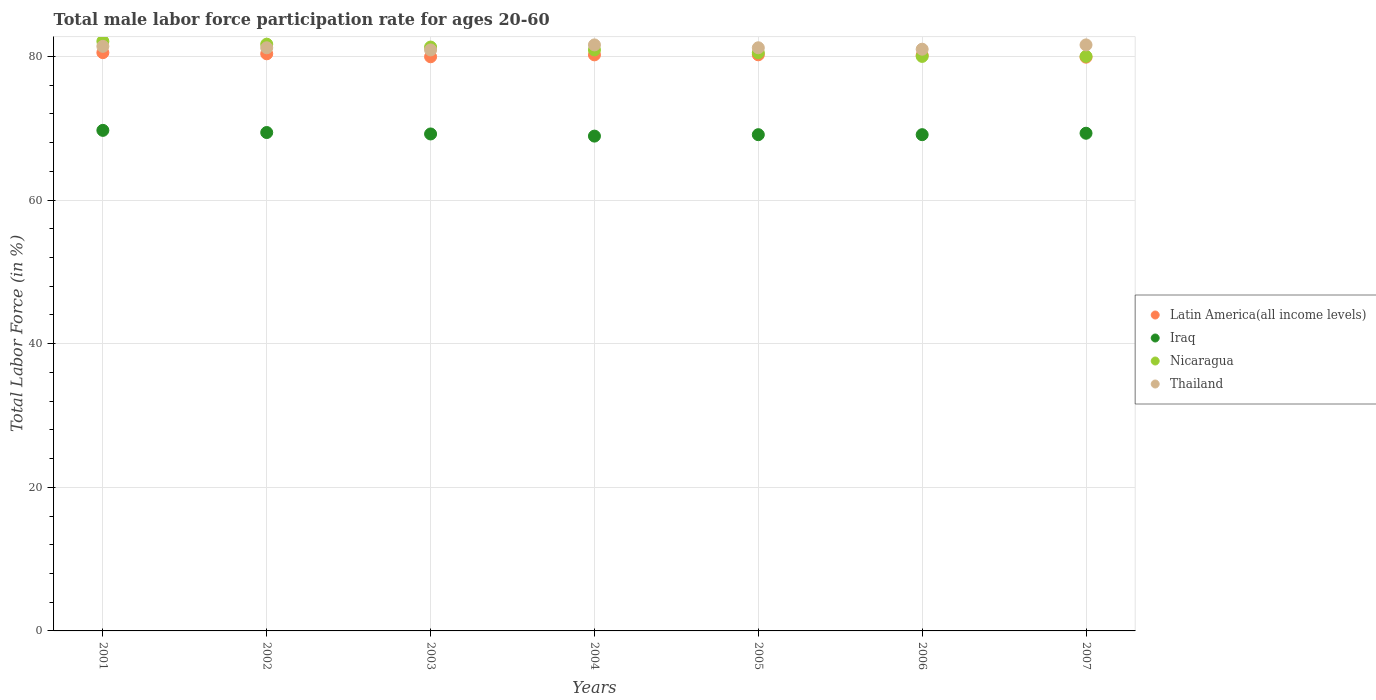What is the male labor force participation rate in Iraq in 2001?
Offer a terse response. 69.7. Across all years, what is the maximum male labor force participation rate in Thailand?
Your answer should be compact. 81.6. In which year was the male labor force participation rate in Thailand maximum?
Your response must be concise. 2004. In which year was the male labor force participation rate in Latin America(all income levels) minimum?
Your answer should be compact. 2007. What is the total male labor force participation rate in Nicaragua in the graph?
Ensure brevity in your answer.  566.5. What is the difference between the male labor force participation rate in Iraq in 2003 and that in 2004?
Your answer should be compact. 0.3. What is the difference between the male labor force participation rate in Latin America(all income levels) in 2006 and the male labor force participation rate in Nicaragua in 2001?
Offer a terse response. -1.94. What is the average male labor force participation rate in Thailand per year?
Give a very brief answer. 81.27. In the year 2006, what is the difference between the male labor force participation rate in Iraq and male labor force participation rate in Thailand?
Offer a very short reply. -11.9. What is the ratio of the male labor force participation rate in Latin America(all income levels) in 2003 to that in 2004?
Make the answer very short. 1. What is the difference between the highest and the second highest male labor force participation rate in Iraq?
Your answer should be very brief. 0.3. What is the difference between the highest and the lowest male labor force participation rate in Latin America(all income levels)?
Provide a succinct answer. 0.63. In how many years, is the male labor force participation rate in Thailand greater than the average male labor force participation rate in Thailand taken over all years?
Your answer should be very brief. 3. Is it the case that in every year, the sum of the male labor force participation rate in Iraq and male labor force participation rate in Latin America(all income levels)  is greater than the sum of male labor force participation rate in Thailand and male labor force participation rate in Nicaragua?
Provide a succinct answer. No. Does the male labor force participation rate in Latin America(all income levels) monotonically increase over the years?
Your answer should be compact. No. Is the male labor force participation rate in Nicaragua strictly less than the male labor force participation rate in Latin America(all income levels) over the years?
Your response must be concise. No. How many dotlines are there?
Offer a terse response. 4. How many years are there in the graph?
Your answer should be compact. 7. What is the difference between two consecutive major ticks on the Y-axis?
Ensure brevity in your answer.  20. Are the values on the major ticks of Y-axis written in scientific E-notation?
Provide a short and direct response. No. How many legend labels are there?
Offer a very short reply. 4. What is the title of the graph?
Keep it short and to the point. Total male labor force participation rate for ages 20-60. Does "Macao" appear as one of the legend labels in the graph?
Ensure brevity in your answer.  No. What is the label or title of the Y-axis?
Offer a very short reply. Total Labor Force (in %). What is the Total Labor Force (in %) in Latin America(all income levels) in 2001?
Make the answer very short. 80.52. What is the Total Labor Force (in %) in Iraq in 2001?
Your response must be concise. 69.7. What is the Total Labor Force (in %) in Nicaragua in 2001?
Your answer should be very brief. 82.1. What is the Total Labor Force (in %) of Thailand in 2001?
Ensure brevity in your answer.  81.4. What is the Total Labor Force (in %) in Latin America(all income levels) in 2002?
Ensure brevity in your answer.  80.36. What is the Total Labor Force (in %) in Iraq in 2002?
Offer a very short reply. 69.4. What is the Total Labor Force (in %) in Nicaragua in 2002?
Keep it short and to the point. 81.7. What is the Total Labor Force (in %) of Thailand in 2002?
Your response must be concise. 81.2. What is the Total Labor Force (in %) in Latin America(all income levels) in 2003?
Give a very brief answer. 79.95. What is the Total Labor Force (in %) of Iraq in 2003?
Ensure brevity in your answer.  69.2. What is the Total Labor Force (in %) in Nicaragua in 2003?
Your answer should be compact. 81.3. What is the Total Labor Force (in %) of Thailand in 2003?
Provide a short and direct response. 80.9. What is the Total Labor Force (in %) in Latin America(all income levels) in 2004?
Offer a very short reply. 80.22. What is the Total Labor Force (in %) in Iraq in 2004?
Your answer should be compact. 68.9. What is the Total Labor Force (in %) of Nicaragua in 2004?
Your answer should be very brief. 80.9. What is the Total Labor Force (in %) of Thailand in 2004?
Give a very brief answer. 81.6. What is the Total Labor Force (in %) in Latin America(all income levels) in 2005?
Provide a succinct answer. 80.22. What is the Total Labor Force (in %) in Iraq in 2005?
Your response must be concise. 69.1. What is the Total Labor Force (in %) in Nicaragua in 2005?
Offer a very short reply. 80.5. What is the Total Labor Force (in %) of Thailand in 2005?
Offer a terse response. 81.2. What is the Total Labor Force (in %) in Latin America(all income levels) in 2006?
Your response must be concise. 80.16. What is the Total Labor Force (in %) of Iraq in 2006?
Offer a very short reply. 69.1. What is the Total Labor Force (in %) in Thailand in 2006?
Offer a very short reply. 81. What is the Total Labor Force (in %) of Latin America(all income levels) in 2007?
Your answer should be very brief. 79.89. What is the Total Labor Force (in %) in Iraq in 2007?
Provide a succinct answer. 69.3. What is the Total Labor Force (in %) in Nicaragua in 2007?
Make the answer very short. 80. What is the Total Labor Force (in %) in Thailand in 2007?
Provide a succinct answer. 81.6. Across all years, what is the maximum Total Labor Force (in %) in Latin America(all income levels)?
Your answer should be very brief. 80.52. Across all years, what is the maximum Total Labor Force (in %) in Iraq?
Your answer should be compact. 69.7. Across all years, what is the maximum Total Labor Force (in %) in Nicaragua?
Provide a short and direct response. 82.1. Across all years, what is the maximum Total Labor Force (in %) in Thailand?
Give a very brief answer. 81.6. Across all years, what is the minimum Total Labor Force (in %) of Latin America(all income levels)?
Your response must be concise. 79.89. Across all years, what is the minimum Total Labor Force (in %) in Iraq?
Make the answer very short. 68.9. Across all years, what is the minimum Total Labor Force (in %) of Thailand?
Provide a short and direct response. 80.9. What is the total Total Labor Force (in %) in Latin America(all income levels) in the graph?
Offer a terse response. 561.32. What is the total Total Labor Force (in %) in Iraq in the graph?
Your answer should be very brief. 484.7. What is the total Total Labor Force (in %) in Nicaragua in the graph?
Your answer should be compact. 566.5. What is the total Total Labor Force (in %) of Thailand in the graph?
Provide a short and direct response. 568.9. What is the difference between the Total Labor Force (in %) in Latin America(all income levels) in 2001 and that in 2002?
Give a very brief answer. 0.16. What is the difference between the Total Labor Force (in %) in Thailand in 2001 and that in 2002?
Keep it short and to the point. 0.2. What is the difference between the Total Labor Force (in %) of Latin America(all income levels) in 2001 and that in 2003?
Provide a succinct answer. 0.57. What is the difference between the Total Labor Force (in %) in Latin America(all income levels) in 2001 and that in 2004?
Your answer should be compact. 0.3. What is the difference between the Total Labor Force (in %) of Nicaragua in 2001 and that in 2004?
Provide a short and direct response. 1.2. What is the difference between the Total Labor Force (in %) in Latin America(all income levels) in 2001 and that in 2005?
Your answer should be compact. 0.3. What is the difference between the Total Labor Force (in %) of Nicaragua in 2001 and that in 2005?
Keep it short and to the point. 1.6. What is the difference between the Total Labor Force (in %) of Thailand in 2001 and that in 2005?
Provide a short and direct response. 0.2. What is the difference between the Total Labor Force (in %) of Latin America(all income levels) in 2001 and that in 2006?
Offer a terse response. 0.36. What is the difference between the Total Labor Force (in %) of Iraq in 2001 and that in 2006?
Provide a succinct answer. 0.6. What is the difference between the Total Labor Force (in %) in Nicaragua in 2001 and that in 2006?
Offer a very short reply. 2.1. What is the difference between the Total Labor Force (in %) in Thailand in 2001 and that in 2006?
Provide a short and direct response. 0.4. What is the difference between the Total Labor Force (in %) of Latin America(all income levels) in 2001 and that in 2007?
Give a very brief answer. 0.63. What is the difference between the Total Labor Force (in %) of Iraq in 2001 and that in 2007?
Give a very brief answer. 0.4. What is the difference between the Total Labor Force (in %) of Thailand in 2001 and that in 2007?
Offer a terse response. -0.2. What is the difference between the Total Labor Force (in %) of Latin America(all income levels) in 2002 and that in 2003?
Make the answer very short. 0.42. What is the difference between the Total Labor Force (in %) of Iraq in 2002 and that in 2003?
Keep it short and to the point. 0.2. What is the difference between the Total Labor Force (in %) of Thailand in 2002 and that in 2003?
Offer a terse response. 0.3. What is the difference between the Total Labor Force (in %) in Latin America(all income levels) in 2002 and that in 2004?
Keep it short and to the point. 0.15. What is the difference between the Total Labor Force (in %) in Iraq in 2002 and that in 2004?
Provide a short and direct response. 0.5. What is the difference between the Total Labor Force (in %) of Latin America(all income levels) in 2002 and that in 2005?
Ensure brevity in your answer.  0.14. What is the difference between the Total Labor Force (in %) in Nicaragua in 2002 and that in 2005?
Provide a succinct answer. 1.2. What is the difference between the Total Labor Force (in %) of Latin America(all income levels) in 2002 and that in 2006?
Give a very brief answer. 0.2. What is the difference between the Total Labor Force (in %) of Latin America(all income levels) in 2002 and that in 2007?
Your response must be concise. 0.47. What is the difference between the Total Labor Force (in %) in Iraq in 2002 and that in 2007?
Make the answer very short. 0.1. What is the difference between the Total Labor Force (in %) in Nicaragua in 2002 and that in 2007?
Keep it short and to the point. 1.7. What is the difference between the Total Labor Force (in %) of Latin America(all income levels) in 2003 and that in 2004?
Keep it short and to the point. -0.27. What is the difference between the Total Labor Force (in %) of Thailand in 2003 and that in 2004?
Your response must be concise. -0.7. What is the difference between the Total Labor Force (in %) in Latin America(all income levels) in 2003 and that in 2005?
Provide a succinct answer. -0.27. What is the difference between the Total Labor Force (in %) in Nicaragua in 2003 and that in 2005?
Keep it short and to the point. 0.8. What is the difference between the Total Labor Force (in %) in Thailand in 2003 and that in 2005?
Ensure brevity in your answer.  -0.3. What is the difference between the Total Labor Force (in %) of Latin America(all income levels) in 2003 and that in 2006?
Keep it short and to the point. -0.21. What is the difference between the Total Labor Force (in %) in Nicaragua in 2003 and that in 2006?
Provide a short and direct response. 1.3. What is the difference between the Total Labor Force (in %) in Thailand in 2003 and that in 2006?
Your answer should be very brief. -0.1. What is the difference between the Total Labor Force (in %) of Latin America(all income levels) in 2003 and that in 2007?
Your answer should be compact. 0.06. What is the difference between the Total Labor Force (in %) in Iraq in 2003 and that in 2007?
Give a very brief answer. -0.1. What is the difference between the Total Labor Force (in %) of Thailand in 2003 and that in 2007?
Keep it short and to the point. -0.7. What is the difference between the Total Labor Force (in %) in Latin America(all income levels) in 2004 and that in 2005?
Offer a terse response. -0.01. What is the difference between the Total Labor Force (in %) in Iraq in 2004 and that in 2005?
Provide a succinct answer. -0.2. What is the difference between the Total Labor Force (in %) in Nicaragua in 2004 and that in 2005?
Provide a short and direct response. 0.4. What is the difference between the Total Labor Force (in %) of Thailand in 2004 and that in 2005?
Offer a terse response. 0.4. What is the difference between the Total Labor Force (in %) in Latin America(all income levels) in 2004 and that in 2006?
Keep it short and to the point. 0.05. What is the difference between the Total Labor Force (in %) of Nicaragua in 2004 and that in 2006?
Keep it short and to the point. 0.9. What is the difference between the Total Labor Force (in %) in Thailand in 2004 and that in 2006?
Your answer should be compact. 0.6. What is the difference between the Total Labor Force (in %) in Latin America(all income levels) in 2004 and that in 2007?
Provide a succinct answer. 0.32. What is the difference between the Total Labor Force (in %) in Latin America(all income levels) in 2005 and that in 2006?
Give a very brief answer. 0.06. What is the difference between the Total Labor Force (in %) in Iraq in 2005 and that in 2006?
Ensure brevity in your answer.  0. What is the difference between the Total Labor Force (in %) of Thailand in 2005 and that in 2006?
Keep it short and to the point. 0.2. What is the difference between the Total Labor Force (in %) in Latin America(all income levels) in 2005 and that in 2007?
Provide a short and direct response. 0.33. What is the difference between the Total Labor Force (in %) of Iraq in 2005 and that in 2007?
Ensure brevity in your answer.  -0.2. What is the difference between the Total Labor Force (in %) of Thailand in 2005 and that in 2007?
Provide a short and direct response. -0.4. What is the difference between the Total Labor Force (in %) in Latin America(all income levels) in 2006 and that in 2007?
Your answer should be compact. 0.27. What is the difference between the Total Labor Force (in %) in Nicaragua in 2006 and that in 2007?
Your response must be concise. 0. What is the difference between the Total Labor Force (in %) of Latin America(all income levels) in 2001 and the Total Labor Force (in %) of Iraq in 2002?
Your response must be concise. 11.12. What is the difference between the Total Labor Force (in %) in Latin America(all income levels) in 2001 and the Total Labor Force (in %) in Nicaragua in 2002?
Give a very brief answer. -1.18. What is the difference between the Total Labor Force (in %) of Latin America(all income levels) in 2001 and the Total Labor Force (in %) of Thailand in 2002?
Your response must be concise. -0.68. What is the difference between the Total Labor Force (in %) of Iraq in 2001 and the Total Labor Force (in %) of Nicaragua in 2002?
Offer a terse response. -12. What is the difference between the Total Labor Force (in %) in Iraq in 2001 and the Total Labor Force (in %) in Thailand in 2002?
Your response must be concise. -11.5. What is the difference between the Total Labor Force (in %) in Latin America(all income levels) in 2001 and the Total Labor Force (in %) in Iraq in 2003?
Your response must be concise. 11.32. What is the difference between the Total Labor Force (in %) of Latin America(all income levels) in 2001 and the Total Labor Force (in %) of Nicaragua in 2003?
Provide a succinct answer. -0.78. What is the difference between the Total Labor Force (in %) of Latin America(all income levels) in 2001 and the Total Labor Force (in %) of Thailand in 2003?
Ensure brevity in your answer.  -0.38. What is the difference between the Total Labor Force (in %) in Iraq in 2001 and the Total Labor Force (in %) in Nicaragua in 2003?
Provide a short and direct response. -11.6. What is the difference between the Total Labor Force (in %) in Latin America(all income levels) in 2001 and the Total Labor Force (in %) in Iraq in 2004?
Give a very brief answer. 11.62. What is the difference between the Total Labor Force (in %) of Latin America(all income levels) in 2001 and the Total Labor Force (in %) of Nicaragua in 2004?
Ensure brevity in your answer.  -0.38. What is the difference between the Total Labor Force (in %) in Latin America(all income levels) in 2001 and the Total Labor Force (in %) in Thailand in 2004?
Provide a short and direct response. -1.08. What is the difference between the Total Labor Force (in %) in Latin America(all income levels) in 2001 and the Total Labor Force (in %) in Iraq in 2005?
Give a very brief answer. 11.42. What is the difference between the Total Labor Force (in %) in Latin America(all income levels) in 2001 and the Total Labor Force (in %) in Nicaragua in 2005?
Keep it short and to the point. 0.02. What is the difference between the Total Labor Force (in %) in Latin America(all income levels) in 2001 and the Total Labor Force (in %) in Thailand in 2005?
Make the answer very short. -0.68. What is the difference between the Total Labor Force (in %) in Iraq in 2001 and the Total Labor Force (in %) in Nicaragua in 2005?
Offer a very short reply. -10.8. What is the difference between the Total Labor Force (in %) in Iraq in 2001 and the Total Labor Force (in %) in Thailand in 2005?
Your answer should be very brief. -11.5. What is the difference between the Total Labor Force (in %) in Latin America(all income levels) in 2001 and the Total Labor Force (in %) in Iraq in 2006?
Offer a terse response. 11.42. What is the difference between the Total Labor Force (in %) of Latin America(all income levels) in 2001 and the Total Labor Force (in %) of Nicaragua in 2006?
Make the answer very short. 0.52. What is the difference between the Total Labor Force (in %) in Latin America(all income levels) in 2001 and the Total Labor Force (in %) in Thailand in 2006?
Keep it short and to the point. -0.48. What is the difference between the Total Labor Force (in %) in Iraq in 2001 and the Total Labor Force (in %) in Thailand in 2006?
Your response must be concise. -11.3. What is the difference between the Total Labor Force (in %) in Nicaragua in 2001 and the Total Labor Force (in %) in Thailand in 2006?
Provide a succinct answer. 1.1. What is the difference between the Total Labor Force (in %) in Latin America(all income levels) in 2001 and the Total Labor Force (in %) in Iraq in 2007?
Offer a very short reply. 11.22. What is the difference between the Total Labor Force (in %) in Latin America(all income levels) in 2001 and the Total Labor Force (in %) in Nicaragua in 2007?
Ensure brevity in your answer.  0.52. What is the difference between the Total Labor Force (in %) in Latin America(all income levels) in 2001 and the Total Labor Force (in %) in Thailand in 2007?
Your answer should be compact. -1.08. What is the difference between the Total Labor Force (in %) of Latin America(all income levels) in 2002 and the Total Labor Force (in %) of Iraq in 2003?
Give a very brief answer. 11.16. What is the difference between the Total Labor Force (in %) in Latin America(all income levels) in 2002 and the Total Labor Force (in %) in Nicaragua in 2003?
Make the answer very short. -0.94. What is the difference between the Total Labor Force (in %) in Latin America(all income levels) in 2002 and the Total Labor Force (in %) in Thailand in 2003?
Offer a terse response. -0.54. What is the difference between the Total Labor Force (in %) in Iraq in 2002 and the Total Labor Force (in %) in Nicaragua in 2003?
Offer a terse response. -11.9. What is the difference between the Total Labor Force (in %) in Nicaragua in 2002 and the Total Labor Force (in %) in Thailand in 2003?
Your answer should be compact. 0.8. What is the difference between the Total Labor Force (in %) of Latin America(all income levels) in 2002 and the Total Labor Force (in %) of Iraq in 2004?
Provide a short and direct response. 11.46. What is the difference between the Total Labor Force (in %) in Latin America(all income levels) in 2002 and the Total Labor Force (in %) in Nicaragua in 2004?
Make the answer very short. -0.54. What is the difference between the Total Labor Force (in %) of Latin America(all income levels) in 2002 and the Total Labor Force (in %) of Thailand in 2004?
Ensure brevity in your answer.  -1.24. What is the difference between the Total Labor Force (in %) in Iraq in 2002 and the Total Labor Force (in %) in Nicaragua in 2004?
Your answer should be compact. -11.5. What is the difference between the Total Labor Force (in %) in Nicaragua in 2002 and the Total Labor Force (in %) in Thailand in 2004?
Your answer should be very brief. 0.1. What is the difference between the Total Labor Force (in %) in Latin America(all income levels) in 2002 and the Total Labor Force (in %) in Iraq in 2005?
Your answer should be compact. 11.26. What is the difference between the Total Labor Force (in %) of Latin America(all income levels) in 2002 and the Total Labor Force (in %) of Nicaragua in 2005?
Give a very brief answer. -0.14. What is the difference between the Total Labor Force (in %) in Latin America(all income levels) in 2002 and the Total Labor Force (in %) in Thailand in 2005?
Ensure brevity in your answer.  -0.84. What is the difference between the Total Labor Force (in %) in Iraq in 2002 and the Total Labor Force (in %) in Thailand in 2005?
Keep it short and to the point. -11.8. What is the difference between the Total Labor Force (in %) in Latin America(all income levels) in 2002 and the Total Labor Force (in %) in Iraq in 2006?
Offer a very short reply. 11.26. What is the difference between the Total Labor Force (in %) of Latin America(all income levels) in 2002 and the Total Labor Force (in %) of Nicaragua in 2006?
Your answer should be compact. 0.36. What is the difference between the Total Labor Force (in %) in Latin America(all income levels) in 2002 and the Total Labor Force (in %) in Thailand in 2006?
Provide a short and direct response. -0.64. What is the difference between the Total Labor Force (in %) in Nicaragua in 2002 and the Total Labor Force (in %) in Thailand in 2006?
Offer a very short reply. 0.7. What is the difference between the Total Labor Force (in %) of Latin America(all income levels) in 2002 and the Total Labor Force (in %) of Iraq in 2007?
Ensure brevity in your answer.  11.06. What is the difference between the Total Labor Force (in %) in Latin America(all income levels) in 2002 and the Total Labor Force (in %) in Nicaragua in 2007?
Offer a very short reply. 0.36. What is the difference between the Total Labor Force (in %) of Latin America(all income levels) in 2002 and the Total Labor Force (in %) of Thailand in 2007?
Provide a succinct answer. -1.24. What is the difference between the Total Labor Force (in %) of Nicaragua in 2002 and the Total Labor Force (in %) of Thailand in 2007?
Your answer should be compact. 0.1. What is the difference between the Total Labor Force (in %) of Latin America(all income levels) in 2003 and the Total Labor Force (in %) of Iraq in 2004?
Make the answer very short. 11.05. What is the difference between the Total Labor Force (in %) in Latin America(all income levels) in 2003 and the Total Labor Force (in %) in Nicaragua in 2004?
Offer a very short reply. -0.95. What is the difference between the Total Labor Force (in %) of Latin America(all income levels) in 2003 and the Total Labor Force (in %) of Thailand in 2004?
Ensure brevity in your answer.  -1.65. What is the difference between the Total Labor Force (in %) of Iraq in 2003 and the Total Labor Force (in %) of Nicaragua in 2004?
Offer a very short reply. -11.7. What is the difference between the Total Labor Force (in %) of Iraq in 2003 and the Total Labor Force (in %) of Thailand in 2004?
Provide a short and direct response. -12.4. What is the difference between the Total Labor Force (in %) of Latin America(all income levels) in 2003 and the Total Labor Force (in %) of Iraq in 2005?
Keep it short and to the point. 10.85. What is the difference between the Total Labor Force (in %) in Latin America(all income levels) in 2003 and the Total Labor Force (in %) in Nicaragua in 2005?
Make the answer very short. -0.55. What is the difference between the Total Labor Force (in %) in Latin America(all income levels) in 2003 and the Total Labor Force (in %) in Thailand in 2005?
Offer a terse response. -1.25. What is the difference between the Total Labor Force (in %) of Iraq in 2003 and the Total Labor Force (in %) of Thailand in 2005?
Your answer should be compact. -12. What is the difference between the Total Labor Force (in %) of Nicaragua in 2003 and the Total Labor Force (in %) of Thailand in 2005?
Your response must be concise. 0.1. What is the difference between the Total Labor Force (in %) in Latin America(all income levels) in 2003 and the Total Labor Force (in %) in Iraq in 2006?
Offer a very short reply. 10.85. What is the difference between the Total Labor Force (in %) in Latin America(all income levels) in 2003 and the Total Labor Force (in %) in Nicaragua in 2006?
Offer a terse response. -0.05. What is the difference between the Total Labor Force (in %) in Latin America(all income levels) in 2003 and the Total Labor Force (in %) in Thailand in 2006?
Provide a succinct answer. -1.05. What is the difference between the Total Labor Force (in %) of Iraq in 2003 and the Total Labor Force (in %) of Thailand in 2006?
Provide a succinct answer. -11.8. What is the difference between the Total Labor Force (in %) of Latin America(all income levels) in 2003 and the Total Labor Force (in %) of Iraq in 2007?
Provide a short and direct response. 10.65. What is the difference between the Total Labor Force (in %) in Latin America(all income levels) in 2003 and the Total Labor Force (in %) in Nicaragua in 2007?
Make the answer very short. -0.05. What is the difference between the Total Labor Force (in %) in Latin America(all income levels) in 2003 and the Total Labor Force (in %) in Thailand in 2007?
Your answer should be very brief. -1.65. What is the difference between the Total Labor Force (in %) in Latin America(all income levels) in 2004 and the Total Labor Force (in %) in Iraq in 2005?
Keep it short and to the point. 11.12. What is the difference between the Total Labor Force (in %) of Latin America(all income levels) in 2004 and the Total Labor Force (in %) of Nicaragua in 2005?
Your answer should be very brief. -0.28. What is the difference between the Total Labor Force (in %) of Latin America(all income levels) in 2004 and the Total Labor Force (in %) of Thailand in 2005?
Your response must be concise. -0.98. What is the difference between the Total Labor Force (in %) in Latin America(all income levels) in 2004 and the Total Labor Force (in %) in Iraq in 2006?
Provide a succinct answer. 11.12. What is the difference between the Total Labor Force (in %) of Latin America(all income levels) in 2004 and the Total Labor Force (in %) of Nicaragua in 2006?
Ensure brevity in your answer.  0.22. What is the difference between the Total Labor Force (in %) in Latin America(all income levels) in 2004 and the Total Labor Force (in %) in Thailand in 2006?
Give a very brief answer. -0.78. What is the difference between the Total Labor Force (in %) of Latin America(all income levels) in 2004 and the Total Labor Force (in %) of Iraq in 2007?
Ensure brevity in your answer.  10.92. What is the difference between the Total Labor Force (in %) of Latin America(all income levels) in 2004 and the Total Labor Force (in %) of Nicaragua in 2007?
Keep it short and to the point. 0.22. What is the difference between the Total Labor Force (in %) of Latin America(all income levels) in 2004 and the Total Labor Force (in %) of Thailand in 2007?
Provide a succinct answer. -1.38. What is the difference between the Total Labor Force (in %) of Iraq in 2004 and the Total Labor Force (in %) of Nicaragua in 2007?
Make the answer very short. -11.1. What is the difference between the Total Labor Force (in %) of Iraq in 2004 and the Total Labor Force (in %) of Thailand in 2007?
Your answer should be very brief. -12.7. What is the difference between the Total Labor Force (in %) in Nicaragua in 2004 and the Total Labor Force (in %) in Thailand in 2007?
Make the answer very short. -0.7. What is the difference between the Total Labor Force (in %) of Latin America(all income levels) in 2005 and the Total Labor Force (in %) of Iraq in 2006?
Provide a succinct answer. 11.12. What is the difference between the Total Labor Force (in %) of Latin America(all income levels) in 2005 and the Total Labor Force (in %) of Nicaragua in 2006?
Offer a terse response. 0.22. What is the difference between the Total Labor Force (in %) of Latin America(all income levels) in 2005 and the Total Labor Force (in %) of Thailand in 2006?
Offer a terse response. -0.78. What is the difference between the Total Labor Force (in %) in Iraq in 2005 and the Total Labor Force (in %) in Thailand in 2006?
Provide a short and direct response. -11.9. What is the difference between the Total Labor Force (in %) of Nicaragua in 2005 and the Total Labor Force (in %) of Thailand in 2006?
Offer a very short reply. -0.5. What is the difference between the Total Labor Force (in %) in Latin America(all income levels) in 2005 and the Total Labor Force (in %) in Iraq in 2007?
Your answer should be very brief. 10.92. What is the difference between the Total Labor Force (in %) in Latin America(all income levels) in 2005 and the Total Labor Force (in %) in Nicaragua in 2007?
Give a very brief answer. 0.22. What is the difference between the Total Labor Force (in %) of Latin America(all income levels) in 2005 and the Total Labor Force (in %) of Thailand in 2007?
Your answer should be compact. -1.38. What is the difference between the Total Labor Force (in %) of Iraq in 2005 and the Total Labor Force (in %) of Nicaragua in 2007?
Keep it short and to the point. -10.9. What is the difference between the Total Labor Force (in %) of Nicaragua in 2005 and the Total Labor Force (in %) of Thailand in 2007?
Provide a succinct answer. -1.1. What is the difference between the Total Labor Force (in %) in Latin America(all income levels) in 2006 and the Total Labor Force (in %) in Iraq in 2007?
Your answer should be very brief. 10.86. What is the difference between the Total Labor Force (in %) of Latin America(all income levels) in 2006 and the Total Labor Force (in %) of Nicaragua in 2007?
Your response must be concise. 0.16. What is the difference between the Total Labor Force (in %) of Latin America(all income levels) in 2006 and the Total Labor Force (in %) of Thailand in 2007?
Provide a succinct answer. -1.44. What is the average Total Labor Force (in %) in Latin America(all income levels) per year?
Provide a short and direct response. 80.19. What is the average Total Labor Force (in %) of Iraq per year?
Your answer should be very brief. 69.24. What is the average Total Labor Force (in %) of Nicaragua per year?
Make the answer very short. 80.93. What is the average Total Labor Force (in %) in Thailand per year?
Ensure brevity in your answer.  81.27. In the year 2001, what is the difference between the Total Labor Force (in %) in Latin America(all income levels) and Total Labor Force (in %) in Iraq?
Your response must be concise. 10.82. In the year 2001, what is the difference between the Total Labor Force (in %) in Latin America(all income levels) and Total Labor Force (in %) in Nicaragua?
Your answer should be very brief. -1.58. In the year 2001, what is the difference between the Total Labor Force (in %) in Latin America(all income levels) and Total Labor Force (in %) in Thailand?
Provide a succinct answer. -0.88. In the year 2001, what is the difference between the Total Labor Force (in %) of Iraq and Total Labor Force (in %) of Thailand?
Give a very brief answer. -11.7. In the year 2002, what is the difference between the Total Labor Force (in %) of Latin America(all income levels) and Total Labor Force (in %) of Iraq?
Provide a short and direct response. 10.96. In the year 2002, what is the difference between the Total Labor Force (in %) in Latin America(all income levels) and Total Labor Force (in %) in Nicaragua?
Your response must be concise. -1.34. In the year 2002, what is the difference between the Total Labor Force (in %) of Latin America(all income levels) and Total Labor Force (in %) of Thailand?
Offer a very short reply. -0.84. In the year 2002, what is the difference between the Total Labor Force (in %) of Iraq and Total Labor Force (in %) of Nicaragua?
Keep it short and to the point. -12.3. In the year 2003, what is the difference between the Total Labor Force (in %) in Latin America(all income levels) and Total Labor Force (in %) in Iraq?
Keep it short and to the point. 10.75. In the year 2003, what is the difference between the Total Labor Force (in %) in Latin America(all income levels) and Total Labor Force (in %) in Nicaragua?
Offer a very short reply. -1.35. In the year 2003, what is the difference between the Total Labor Force (in %) of Latin America(all income levels) and Total Labor Force (in %) of Thailand?
Ensure brevity in your answer.  -0.95. In the year 2003, what is the difference between the Total Labor Force (in %) of Nicaragua and Total Labor Force (in %) of Thailand?
Your answer should be very brief. 0.4. In the year 2004, what is the difference between the Total Labor Force (in %) in Latin America(all income levels) and Total Labor Force (in %) in Iraq?
Offer a terse response. 11.32. In the year 2004, what is the difference between the Total Labor Force (in %) in Latin America(all income levels) and Total Labor Force (in %) in Nicaragua?
Offer a terse response. -0.68. In the year 2004, what is the difference between the Total Labor Force (in %) in Latin America(all income levels) and Total Labor Force (in %) in Thailand?
Make the answer very short. -1.38. In the year 2004, what is the difference between the Total Labor Force (in %) of Nicaragua and Total Labor Force (in %) of Thailand?
Offer a terse response. -0.7. In the year 2005, what is the difference between the Total Labor Force (in %) of Latin America(all income levels) and Total Labor Force (in %) of Iraq?
Offer a terse response. 11.12. In the year 2005, what is the difference between the Total Labor Force (in %) of Latin America(all income levels) and Total Labor Force (in %) of Nicaragua?
Make the answer very short. -0.28. In the year 2005, what is the difference between the Total Labor Force (in %) in Latin America(all income levels) and Total Labor Force (in %) in Thailand?
Provide a short and direct response. -0.98. In the year 2005, what is the difference between the Total Labor Force (in %) of Iraq and Total Labor Force (in %) of Nicaragua?
Offer a terse response. -11.4. In the year 2005, what is the difference between the Total Labor Force (in %) in Iraq and Total Labor Force (in %) in Thailand?
Your response must be concise. -12.1. In the year 2006, what is the difference between the Total Labor Force (in %) of Latin America(all income levels) and Total Labor Force (in %) of Iraq?
Your answer should be very brief. 11.06. In the year 2006, what is the difference between the Total Labor Force (in %) in Latin America(all income levels) and Total Labor Force (in %) in Nicaragua?
Your response must be concise. 0.16. In the year 2006, what is the difference between the Total Labor Force (in %) of Latin America(all income levels) and Total Labor Force (in %) of Thailand?
Offer a very short reply. -0.84. In the year 2006, what is the difference between the Total Labor Force (in %) of Iraq and Total Labor Force (in %) of Nicaragua?
Your answer should be compact. -10.9. In the year 2006, what is the difference between the Total Labor Force (in %) of Iraq and Total Labor Force (in %) of Thailand?
Your answer should be very brief. -11.9. In the year 2007, what is the difference between the Total Labor Force (in %) of Latin America(all income levels) and Total Labor Force (in %) of Iraq?
Ensure brevity in your answer.  10.59. In the year 2007, what is the difference between the Total Labor Force (in %) in Latin America(all income levels) and Total Labor Force (in %) in Nicaragua?
Provide a succinct answer. -0.11. In the year 2007, what is the difference between the Total Labor Force (in %) of Latin America(all income levels) and Total Labor Force (in %) of Thailand?
Your answer should be compact. -1.71. In the year 2007, what is the difference between the Total Labor Force (in %) in Nicaragua and Total Labor Force (in %) in Thailand?
Provide a short and direct response. -1.6. What is the ratio of the Total Labor Force (in %) of Iraq in 2001 to that in 2002?
Give a very brief answer. 1. What is the ratio of the Total Labor Force (in %) of Nicaragua in 2001 to that in 2002?
Offer a terse response. 1. What is the ratio of the Total Labor Force (in %) in Iraq in 2001 to that in 2003?
Make the answer very short. 1.01. What is the ratio of the Total Labor Force (in %) in Nicaragua in 2001 to that in 2003?
Give a very brief answer. 1.01. What is the ratio of the Total Labor Force (in %) of Thailand in 2001 to that in 2003?
Give a very brief answer. 1.01. What is the ratio of the Total Labor Force (in %) in Iraq in 2001 to that in 2004?
Give a very brief answer. 1.01. What is the ratio of the Total Labor Force (in %) of Nicaragua in 2001 to that in 2004?
Your answer should be very brief. 1.01. What is the ratio of the Total Labor Force (in %) in Latin America(all income levels) in 2001 to that in 2005?
Keep it short and to the point. 1. What is the ratio of the Total Labor Force (in %) in Iraq in 2001 to that in 2005?
Provide a short and direct response. 1.01. What is the ratio of the Total Labor Force (in %) in Nicaragua in 2001 to that in 2005?
Keep it short and to the point. 1.02. What is the ratio of the Total Labor Force (in %) in Latin America(all income levels) in 2001 to that in 2006?
Give a very brief answer. 1. What is the ratio of the Total Labor Force (in %) of Iraq in 2001 to that in 2006?
Ensure brevity in your answer.  1.01. What is the ratio of the Total Labor Force (in %) of Nicaragua in 2001 to that in 2006?
Offer a terse response. 1.03. What is the ratio of the Total Labor Force (in %) of Thailand in 2001 to that in 2006?
Your answer should be very brief. 1. What is the ratio of the Total Labor Force (in %) in Latin America(all income levels) in 2001 to that in 2007?
Provide a short and direct response. 1.01. What is the ratio of the Total Labor Force (in %) in Iraq in 2001 to that in 2007?
Give a very brief answer. 1.01. What is the ratio of the Total Labor Force (in %) of Nicaragua in 2001 to that in 2007?
Make the answer very short. 1.03. What is the ratio of the Total Labor Force (in %) in Thailand in 2001 to that in 2007?
Provide a succinct answer. 1. What is the ratio of the Total Labor Force (in %) in Nicaragua in 2002 to that in 2003?
Ensure brevity in your answer.  1. What is the ratio of the Total Labor Force (in %) of Iraq in 2002 to that in 2004?
Make the answer very short. 1.01. What is the ratio of the Total Labor Force (in %) in Nicaragua in 2002 to that in 2004?
Your answer should be very brief. 1.01. What is the ratio of the Total Labor Force (in %) in Thailand in 2002 to that in 2004?
Offer a very short reply. 1. What is the ratio of the Total Labor Force (in %) in Latin America(all income levels) in 2002 to that in 2005?
Ensure brevity in your answer.  1. What is the ratio of the Total Labor Force (in %) of Nicaragua in 2002 to that in 2005?
Provide a short and direct response. 1.01. What is the ratio of the Total Labor Force (in %) in Latin America(all income levels) in 2002 to that in 2006?
Provide a succinct answer. 1. What is the ratio of the Total Labor Force (in %) of Nicaragua in 2002 to that in 2006?
Give a very brief answer. 1.02. What is the ratio of the Total Labor Force (in %) in Thailand in 2002 to that in 2006?
Make the answer very short. 1. What is the ratio of the Total Labor Force (in %) of Latin America(all income levels) in 2002 to that in 2007?
Give a very brief answer. 1.01. What is the ratio of the Total Labor Force (in %) of Nicaragua in 2002 to that in 2007?
Make the answer very short. 1.02. What is the ratio of the Total Labor Force (in %) in Latin America(all income levels) in 2003 to that in 2004?
Make the answer very short. 1. What is the ratio of the Total Labor Force (in %) in Iraq in 2003 to that in 2004?
Your answer should be very brief. 1. What is the ratio of the Total Labor Force (in %) of Latin America(all income levels) in 2003 to that in 2005?
Provide a short and direct response. 1. What is the ratio of the Total Labor Force (in %) in Iraq in 2003 to that in 2005?
Offer a terse response. 1. What is the ratio of the Total Labor Force (in %) in Nicaragua in 2003 to that in 2005?
Provide a succinct answer. 1.01. What is the ratio of the Total Labor Force (in %) of Thailand in 2003 to that in 2005?
Provide a short and direct response. 1. What is the ratio of the Total Labor Force (in %) in Nicaragua in 2003 to that in 2006?
Make the answer very short. 1.02. What is the ratio of the Total Labor Force (in %) in Thailand in 2003 to that in 2006?
Your response must be concise. 1. What is the ratio of the Total Labor Force (in %) in Latin America(all income levels) in 2003 to that in 2007?
Your answer should be compact. 1. What is the ratio of the Total Labor Force (in %) in Nicaragua in 2003 to that in 2007?
Keep it short and to the point. 1.02. What is the ratio of the Total Labor Force (in %) of Thailand in 2003 to that in 2007?
Give a very brief answer. 0.99. What is the ratio of the Total Labor Force (in %) of Nicaragua in 2004 to that in 2005?
Keep it short and to the point. 1. What is the ratio of the Total Labor Force (in %) of Thailand in 2004 to that in 2005?
Offer a very short reply. 1. What is the ratio of the Total Labor Force (in %) of Latin America(all income levels) in 2004 to that in 2006?
Your answer should be compact. 1. What is the ratio of the Total Labor Force (in %) in Nicaragua in 2004 to that in 2006?
Provide a succinct answer. 1.01. What is the ratio of the Total Labor Force (in %) in Thailand in 2004 to that in 2006?
Provide a short and direct response. 1.01. What is the ratio of the Total Labor Force (in %) of Latin America(all income levels) in 2004 to that in 2007?
Give a very brief answer. 1. What is the ratio of the Total Labor Force (in %) in Nicaragua in 2004 to that in 2007?
Make the answer very short. 1.01. What is the ratio of the Total Labor Force (in %) of Nicaragua in 2005 to that in 2006?
Offer a terse response. 1.01. What is the ratio of the Total Labor Force (in %) of Thailand in 2005 to that in 2006?
Provide a succinct answer. 1. What is the ratio of the Total Labor Force (in %) of Iraq in 2005 to that in 2007?
Make the answer very short. 1. What is the ratio of the Total Labor Force (in %) in Latin America(all income levels) in 2006 to that in 2007?
Provide a succinct answer. 1. What is the ratio of the Total Labor Force (in %) in Iraq in 2006 to that in 2007?
Your answer should be very brief. 1. What is the difference between the highest and the second highest Total Labor Force (in %) in Latin America(all income levels)?
Keep it short and to the point. 0.16. What is the difference between the highest and the second highest Total Labor Force (in %) in Nicaragua?
Your answer should be very brief. 0.4. What is the difference between the highest and the second highest Total Labor Force (in %) in Thailand?
Keep it short and to the point. 0. What is the difference between the highest and the lowest Total Labor Force (in %) in Latin America(all income levels)?
Your answer should be very brief. 0.63. What is the difference between the highest and the lowest Total Labor Force (in %) in Iraq?
Provide a short and direct response. 0.8. 